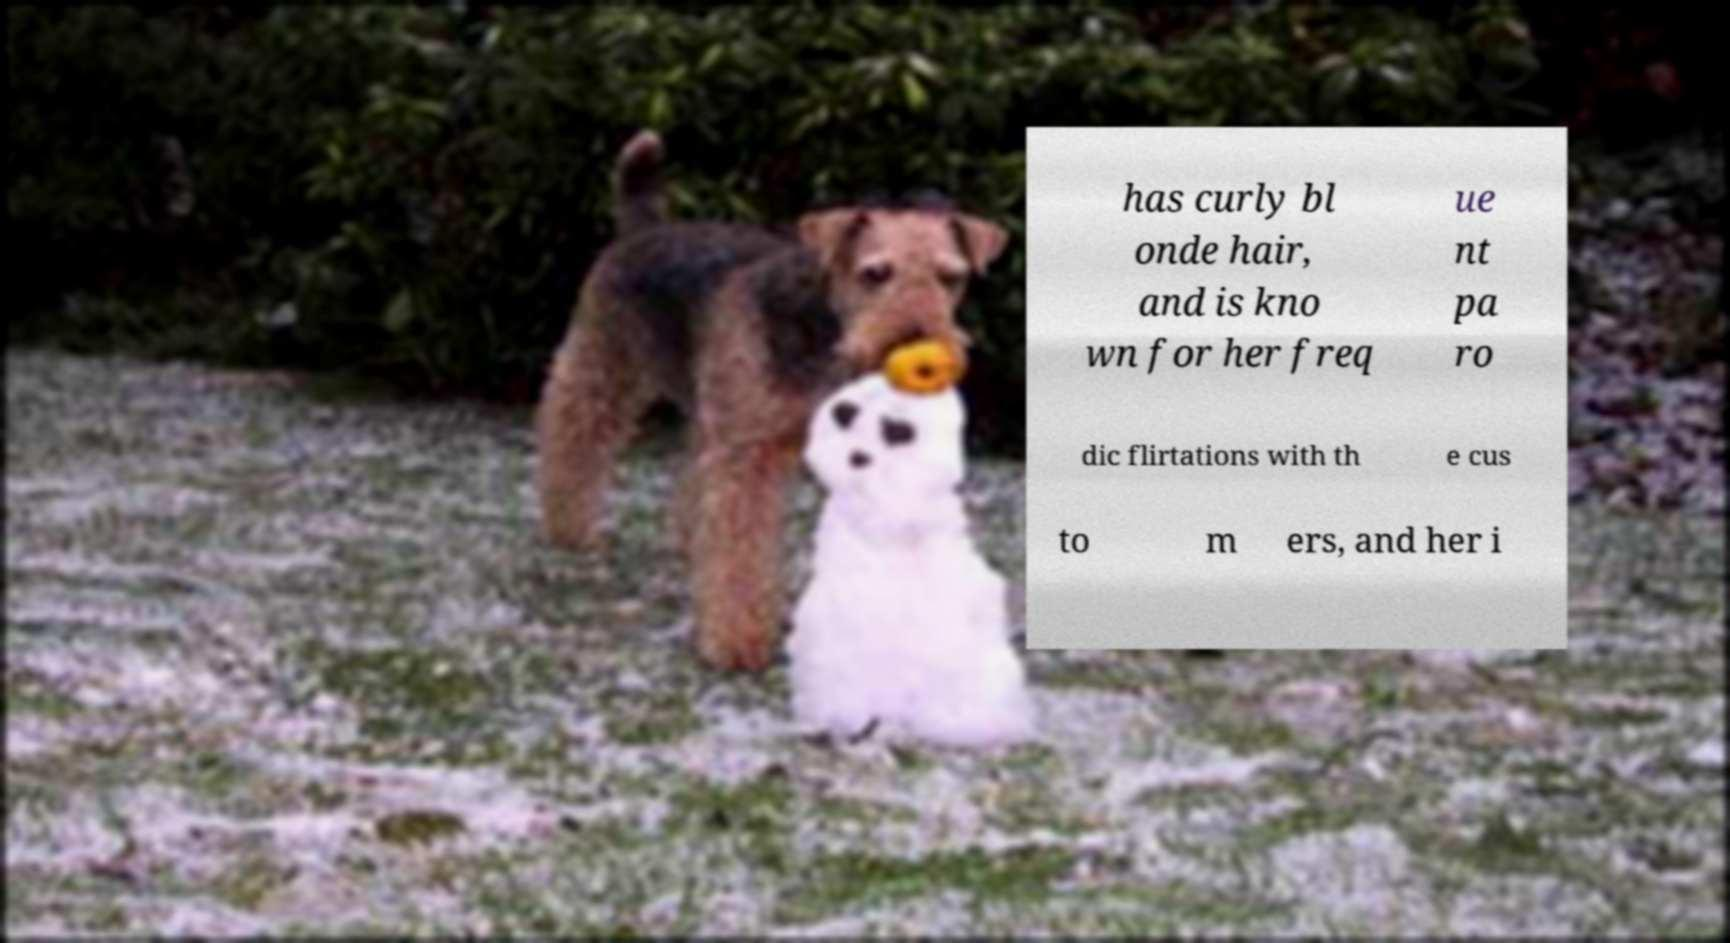Please read and relay the text visible in this image. What does it say? has curly bl onde hair, and is kno wn for her freq ue nt pa ro dic flirtations with th e cus to m ers, and her i 